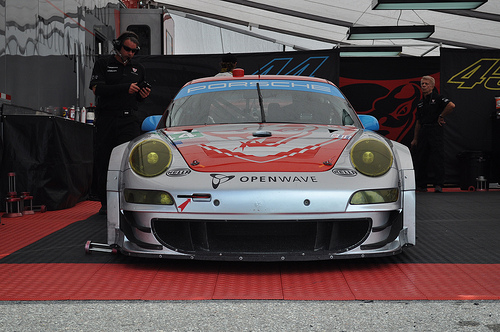<image>
Is the man on the car? No. The man is not positioned on the car. They may be near each other, but the man is not supported by or resting on top of the car. 